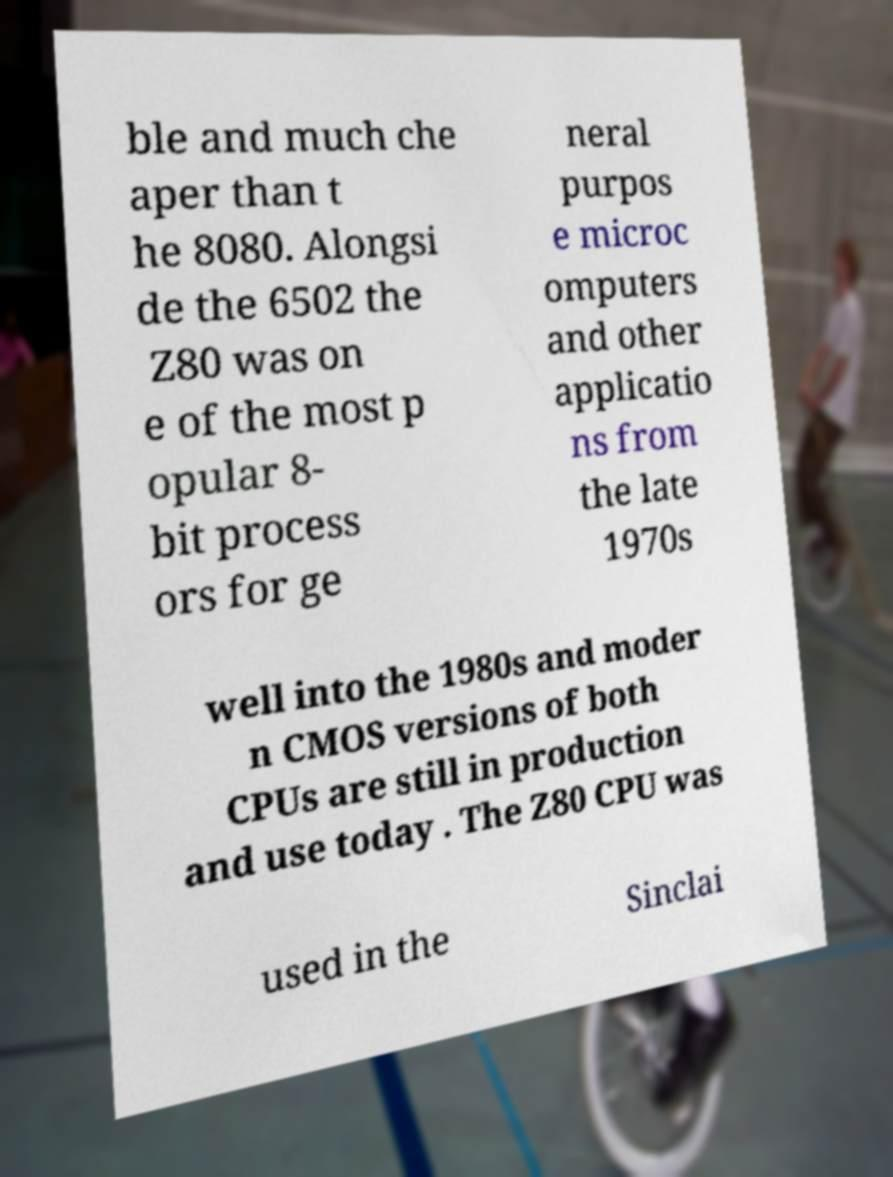Please identify and transcribe the text found in this image. ble and much che aper than t he 8080. Alongsi de the 6502 the Z80 was on e of the most p opular 8- bit process ors for ge neral purpos e microc omputers and other applicatio ns from the late 1970s well into the 1980s and moder n CMOS versions of both CPUs are still in production and use today . The Z80 CPU was used in the Sinclai 